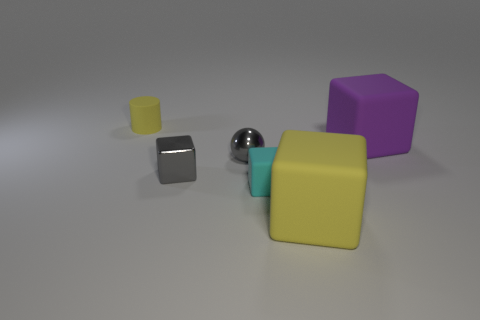There is a yellow matte object that is the same shape as the small cyan matte thing; what size is it? large 